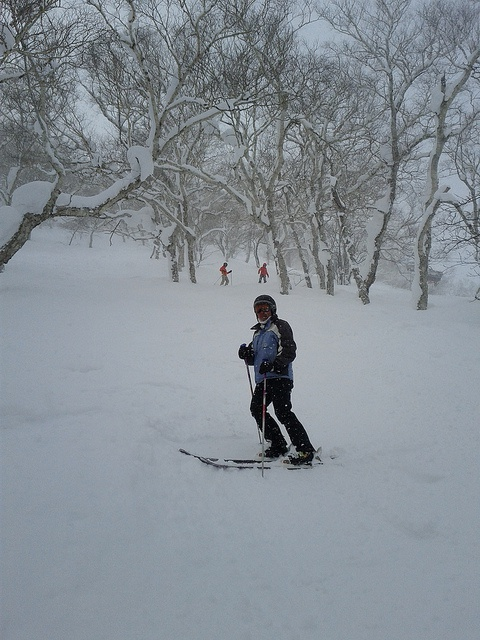Describe the objects in this image and their specific colors. I can see people in gray, black, navy, and darkgray tones, skis in gray, darkgray, and black tones, people in gray, darkgray, maroon, and black tones, and people in gray, brown, darkgray, and black tones in this image. 